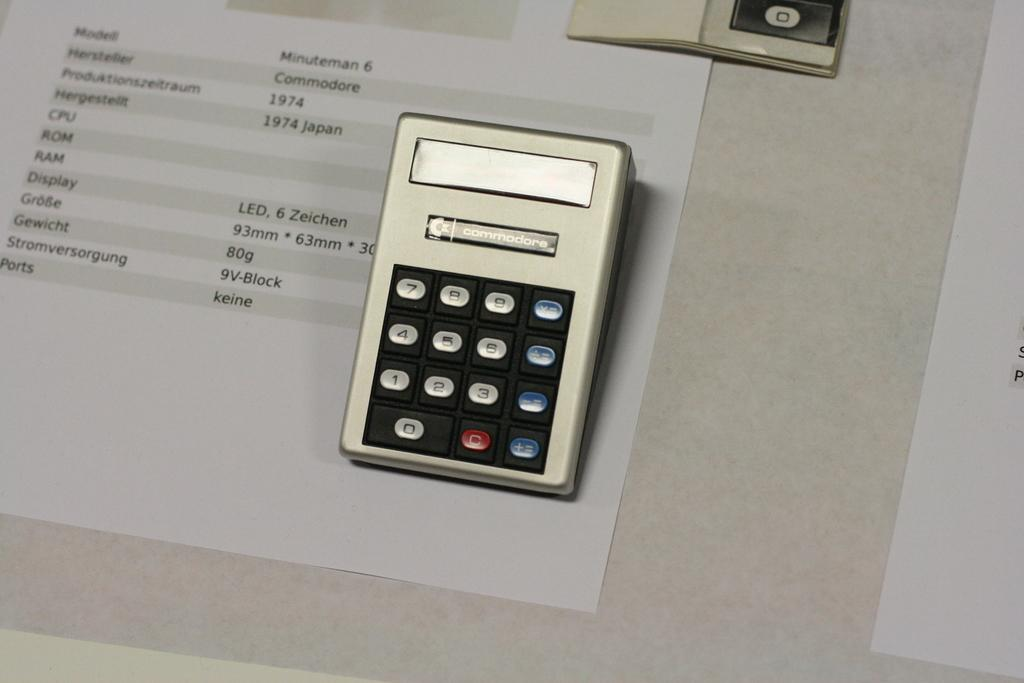<image>
Provide a brief description of the given image. A calculator which has the word Commodore on it. 